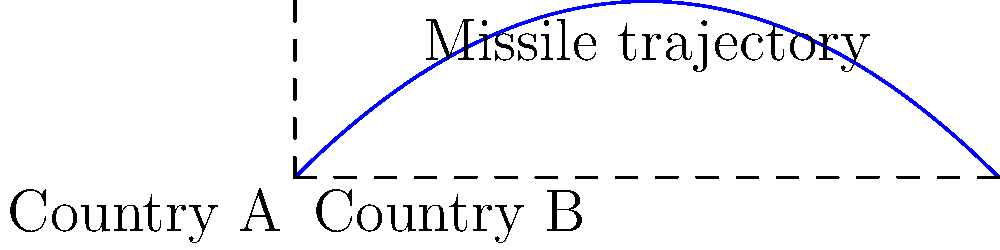A rogue nation, Country A, launches a missile towards its rival, Country B, which is 500 km away. The missile is launched at an angle of 45° with an initial velocity of 800 m/s. Assuming no air resistance and neglecting the Earth's curvature, will the missile reach its target? If not, how far short will it fall? To solve this problem, we'll use the equations of projectile motion:

1) First, calculate the time of flight:
   $$t_{flight} = \frac{2v_0 \sin\theta}{g} = \frac{2 \cdot 800 \cdot \sin(45°)}{9.8} \approx 115.47 \text{ s}$$

2) Now, calculate the maximum horizontal distance:
   $$x_{max} = v_0 \cos\theta \cdot t_{flight} = 800 \cdot \cos(45°) \cdot 115.47 \approx 65,320 \text{ m} = 65.32 \text{ km}$$

3) The target distance is 500 km, which is much greater than the maximum range of 65.32 km.

4) Calculate the distance short:
   $$\text{Distance short} = 500 \text{ km} - 65.32 \text{ km} = 434.68 \text{ km}$$

This scenario illustrates how even advanced weaponry has limitations due to physical constraints, much like how foreign aid often falls short of solving complex geopolitical issues.
Answer: The missile will fall 434.68 km short of its target. 